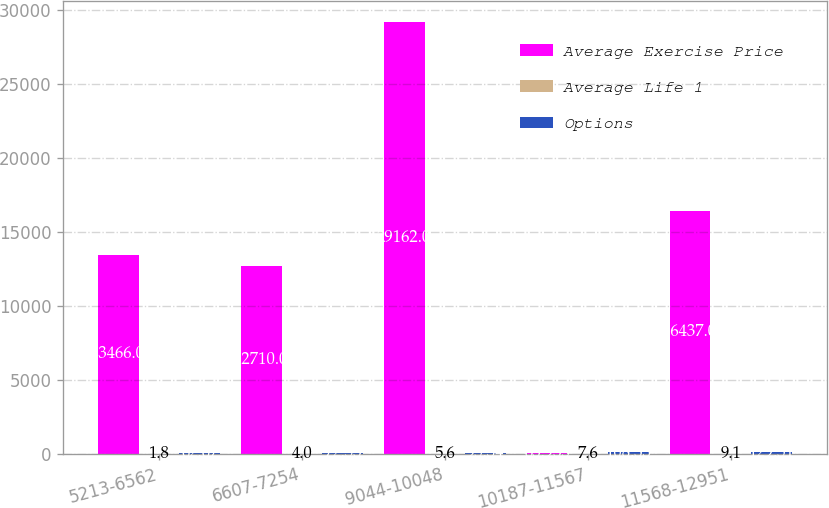Convert chart. <chart><loc_0><loc_0><loc_500><loc_500><stacked_bar_chart><ecel><fcel>5213-6562<fcel>6607-7254<fcel>9044-10048<fcel>10187-11567<fcel>11568-12951<nl><fcel>Average Exercise Price<fcel>13466<fcel>12710<fcel>29162<fcel>83.935<fcel>16437<nl><fcel>Average Life 1<fcel>1.8<fcel>4<fcel>5.6<fcel>7.6<fcel>9.1<nl><fcel>Options<fcel>62.67<fcel>72.53<fcel>95.34<fcel>108.33<fcel>129.51<nl></chart> 